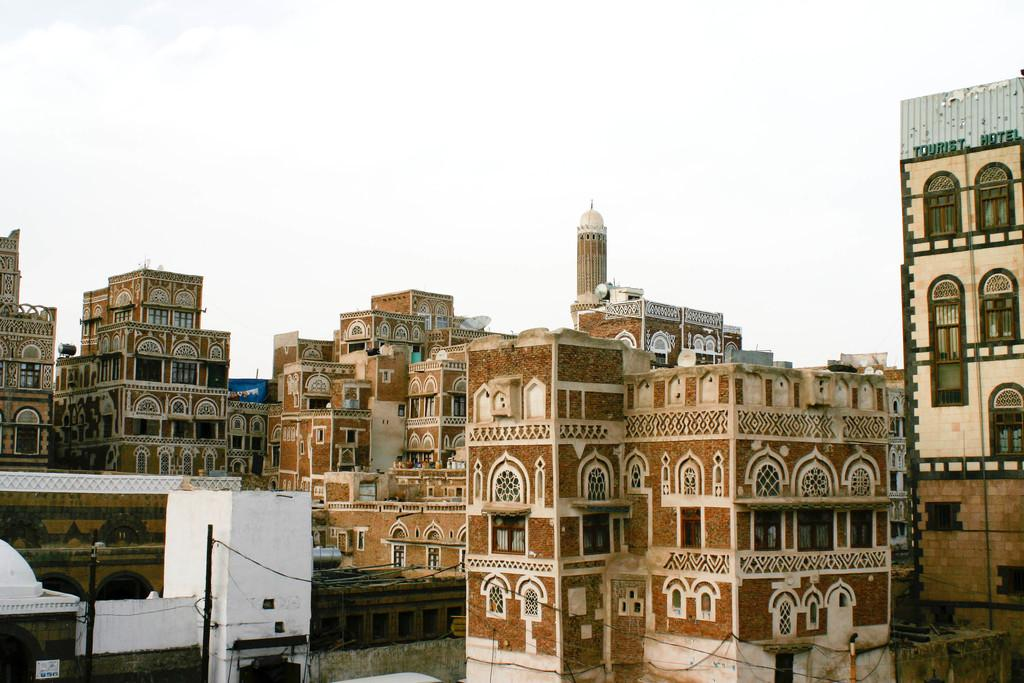What type of structures can be seen in the image? There are buildings in the image. What is located at the bottom of the image? There are two poles and wires at the bottom of the image. What is visible at the top of the image? The sky is visible at the top of the image. Which direction is the image facing, north or south? The image does not indicate a specific direction, so it cannot be determined whether it is facing north or south. 